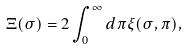<formula> <loc_0><loc_0><loc_500><loc_500>\Xi ( \sigma ) = 2 \int _ { 0 } ^ { \infty } d \pi \xi ( \sigma , \pi ) ,</formula> 